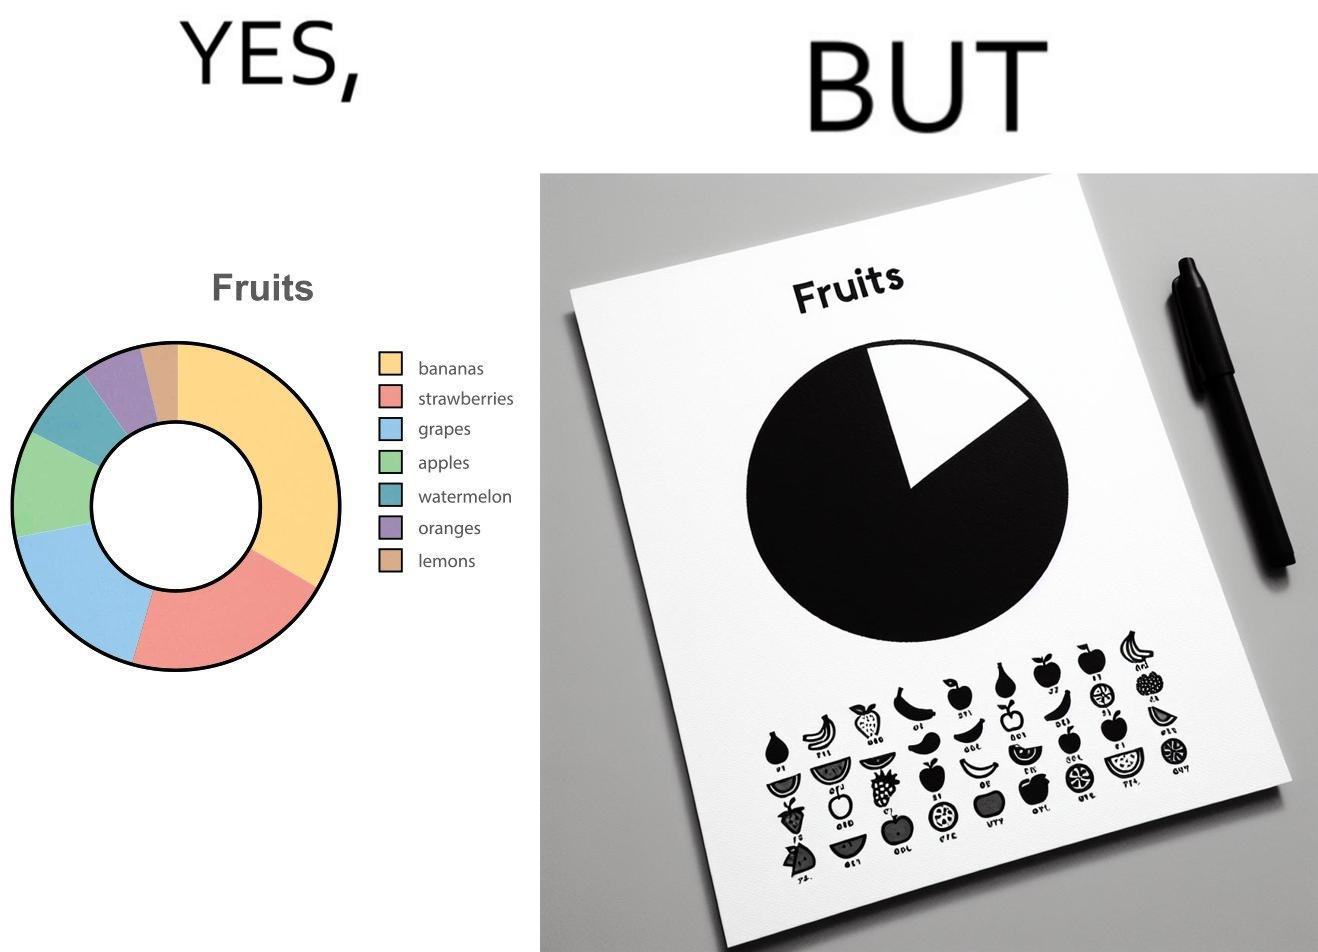Does this image contain satire or humor? Yes, this image is satirical. 